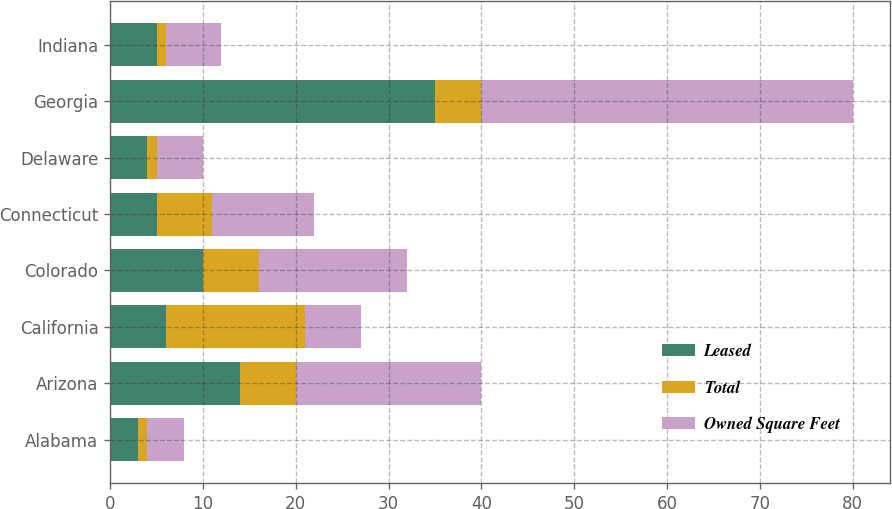Convert chart to OTSL. <chart><loc_0><loc_0><loc_500><loc_500><stacked_bar_chart><ecel><fcel>Alabama<fcel>Arizona<fcel>California<fcel>Colorado<fcel>Connecticut<fcel>Delaware<fcel>Georgia<fcel>Indiana<nl><fcel>Leased<fcel>3<fcel>14<fcel>6<fcel>10<fcel>5<fcel>4<fcel>35<fcel>5<nl><fcel>Total<fcel>1<fcel>6<fcel>15<fcel>6<fcel>6<fcel>1<fcel>5<fcel>1<nl><fcel>Owned Square Feet<fcel>4<fcel>20<fcel>6<fcel>16<fcel>11<fcel>5<fcel>40<fcel>6<nl></chart> 